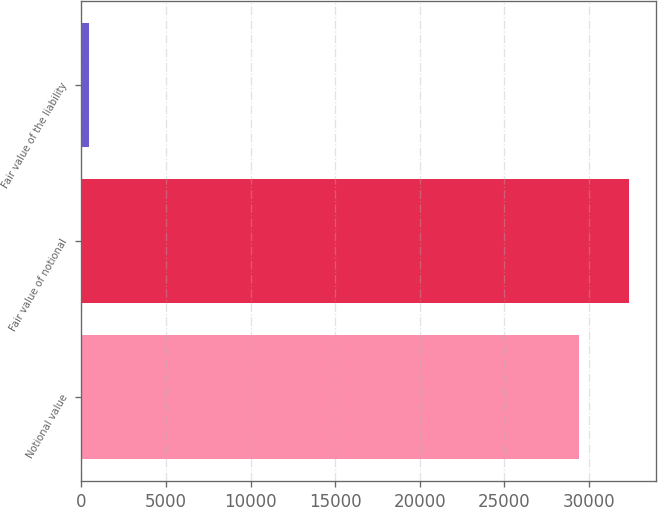<chart> <loc_0><loc_0><loc_500><loc_500><bar_chart><fcel>Notional value<fcel>Fair value of notional<fcel>Fair value of the liability<nl><fcel>29431<fcel>32374.1<fcel>472<nl></chart> 